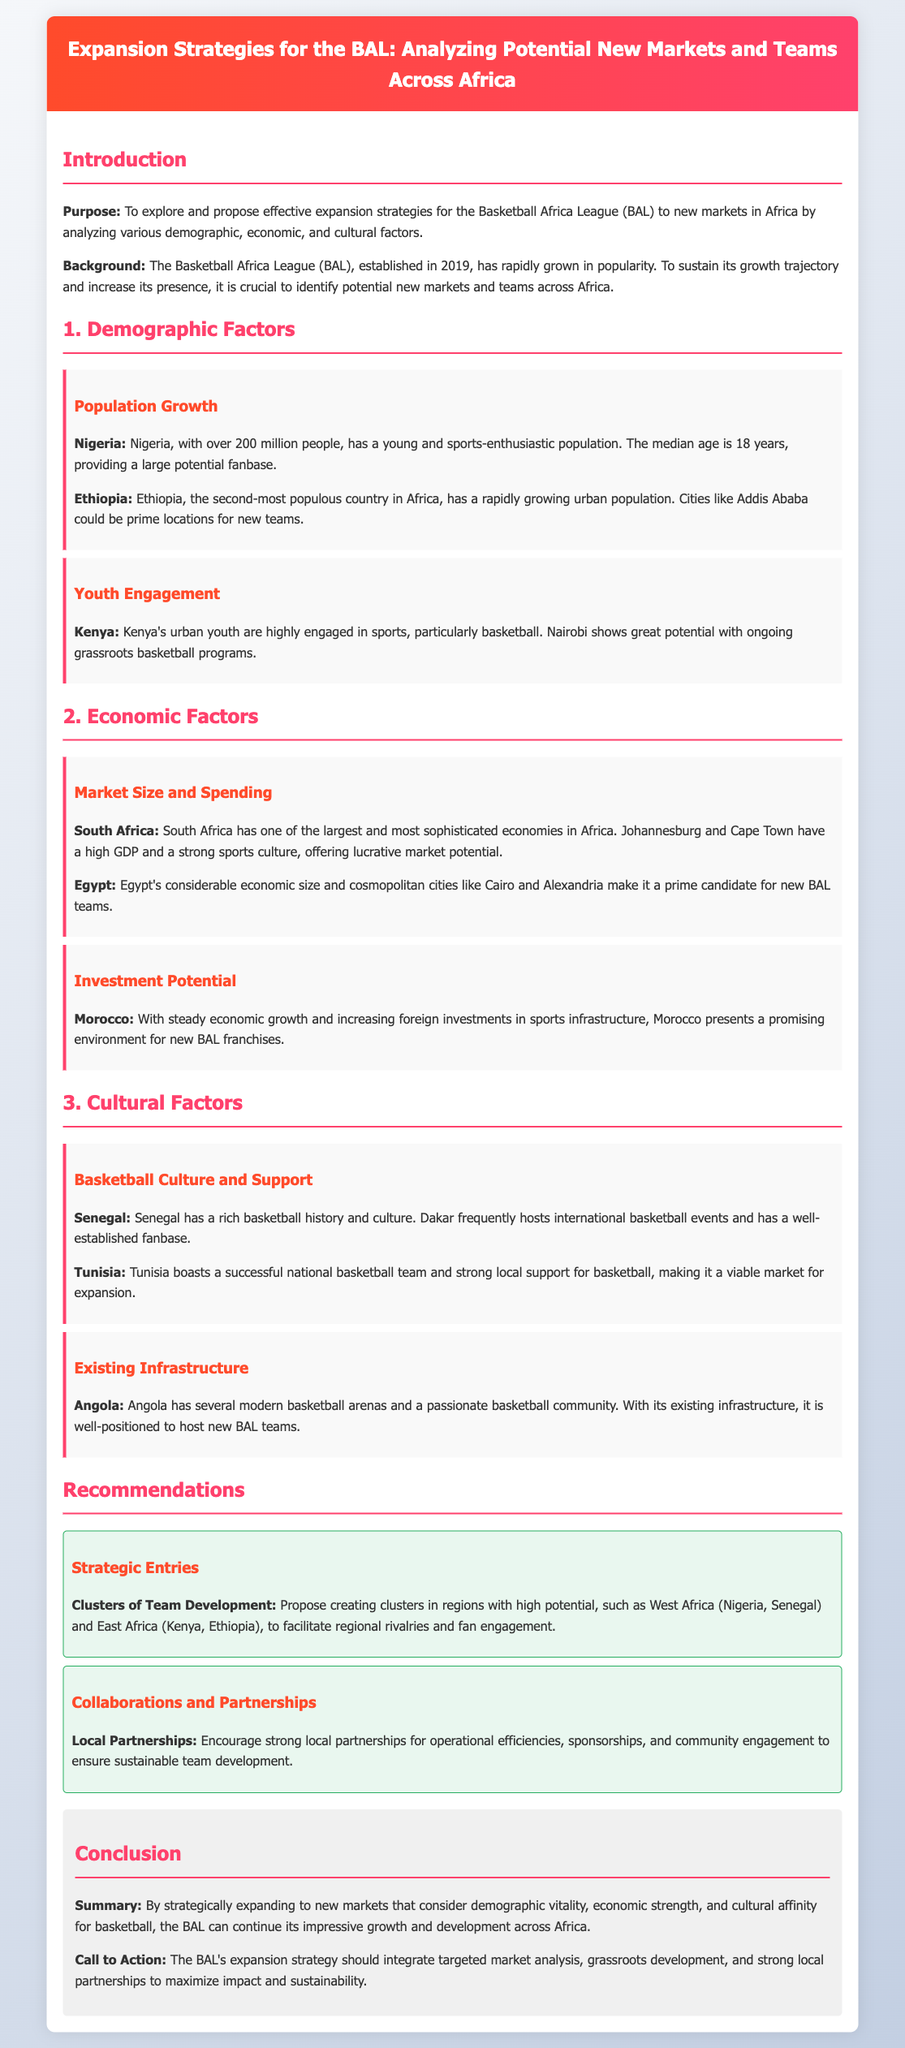What is the primary purpose of the proposal? The purpose is to explore and propose effective expansion strategies for the Basketball Africa League (BAL) to new markets in Africa.
Answer: To explore and propose effective expansion strategies for the Basketball Africa League (BAL) to new markets in Africa Which country has the youngest population according to the document? The document states that Nigeria has a median age of 18 years, indicating it has a young population.
Answer: Nigeria What potential city in Ethiopia is mentioned for new teams? The document highlights Addis Ababa as a prime location for new teams in Ethiopia.
Answer: Addis Ababa What economic characteristic is noted for South Africa? The document describes South Africa as having one of the largest and most sophisticated economies in Africa.
Answer: One of the largest and most sophisticated economies Which country is mentioned as having a rich basketball culture? Senegal is noted for its rich basketball history and culture in the document.
Answer: Senegal How does the proposal suggest facilitating regional rivalries? The recommendation suggests creating clusters in regions like West Africa and East Africa to facilitate regional rivalries.
Answer: Creating clusters in regions What does the proposal recommend for ensuring sustainable team development? The document recommends encouraging strong local partnerships for operational efficiencies and community engagement.
Answer: Strong local partnerships Which two cities in Egypt are mentioned as prime candidates for new BAL teams? The document lists Cairo and Alexandria as prime candidates for new BAL teams in Egypt.
Answer: Cairo and Alexandria What is the call to action stated in the conclusion? The call to action emphasizes the need for integrating targeted market analysis, grassroots development, and strong local partnerships.
Answer: Integrate targeted market analysis, grassroots development, and strong local partnerships 